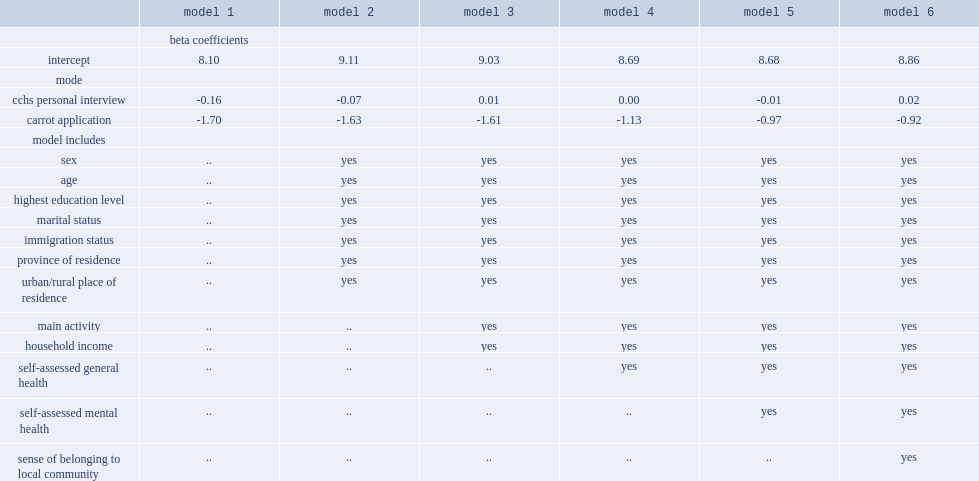How much did individuals who completed the cchs through a personal interview score lower than their cchs counterparts who participated in a telephone interview? 0.16. How much did carrot respondents score lower than their cchs counterparts who had a telephone interview? 1.7. How much did carrot respondents score lower on life satisfaction even after the full set of available covariates were taken into account? 0.92. 